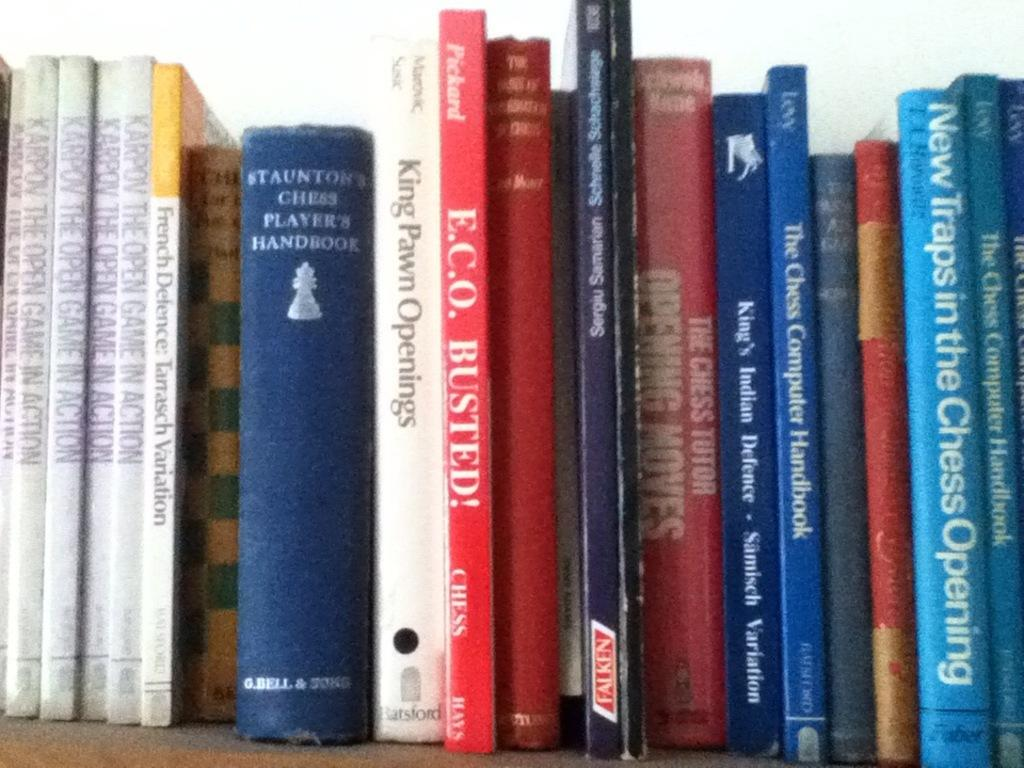<image>
Create a compact narrative representing the image presented. Five books on the shelf have the same title Karpov The Open Game In Action. 